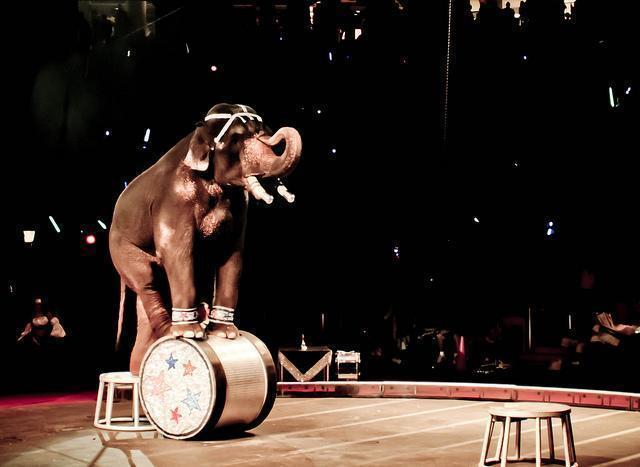Why is the elephant placing its legs on the wheel?
Answer the question by selecting the correct answer among the 4 following choices and explain your choice with a short sentence. The answer should be formatted with the following format: `Answer: choice
Rationale: rationale.`
Options: To scratch, to flip, to kick, to mount. Answer: to mount.
Rationale: The elephant is made to do tricks for the audience. 